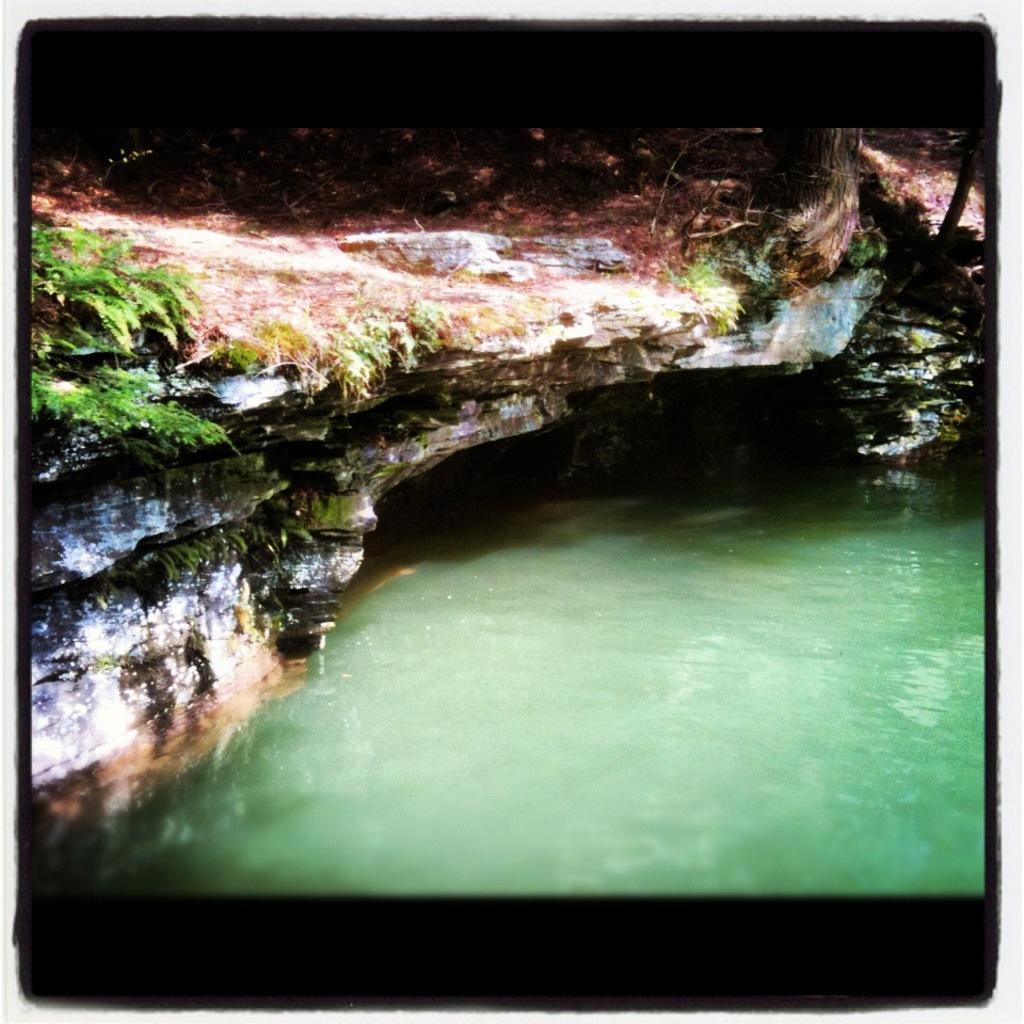In one or two sentences, can you explain what this image depicts? In a foreground of the picture there is water. At the top there are plant, trunk of a tree, grass and a rock. The picture has black border. 